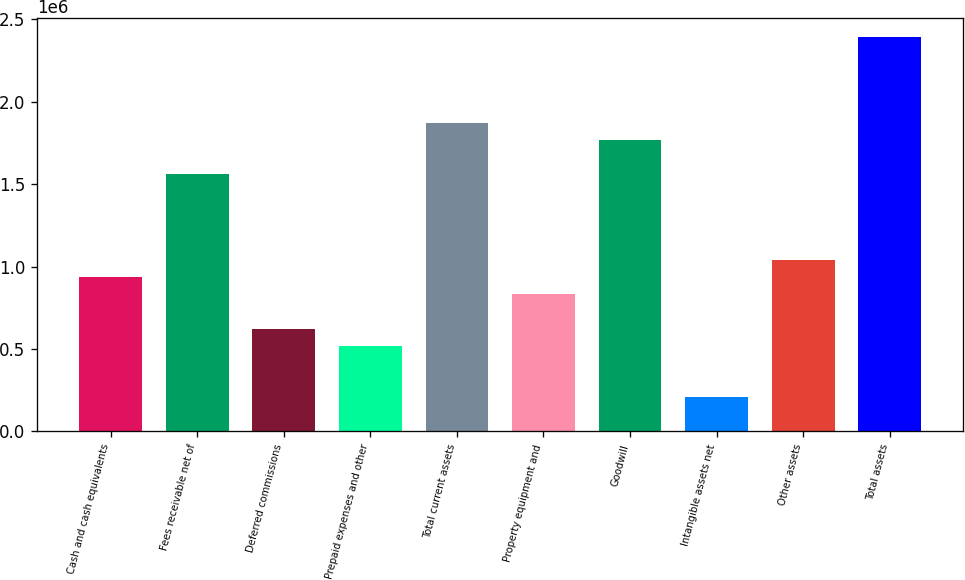<chart> <loc_0><loc_0><loc_500><loc_500><bar_chart><fcel>Cash and cash equivalents<fcel>Fees receivable net of<fcel>Deferred commissions<fcel>Prepaid expenses and other<fcel>Total current assets<fcel>Property equipment and<fcel>Goodwill<fcel>Intangible assets net<fcel>Other assets<fcel>Total assets<nl><fcel>935822<fcel>1.55965e+06<fcel>623907<fcel>519936<fcel>1.87156e+06<fcel>831850<fcel>1.76759e+06<fcel>208021<fcel>1.03979e+06<fcel>2.39142e+06<nl></chart> 